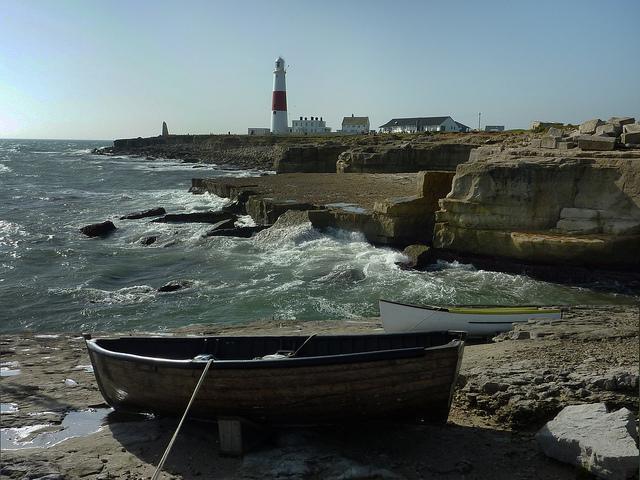How many boats are in the photo?
Give a very brief answer. 2. 